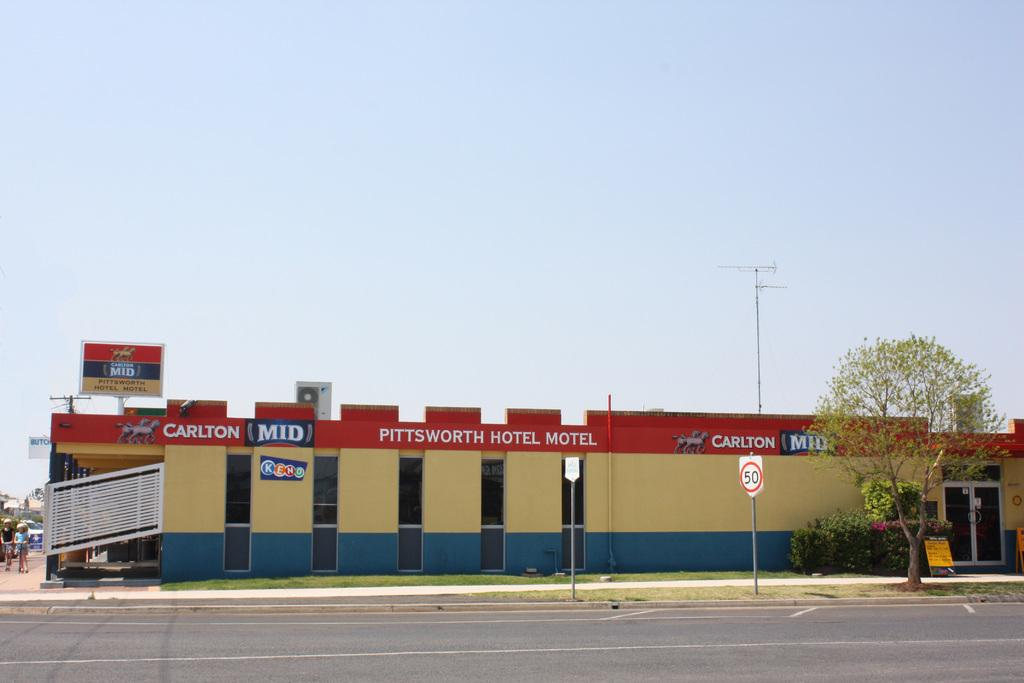What type of building is in the image? There is a hotel in the image. What type of natural elements can be seen in the image? Plants, a tree, and the sky are visible in the image. What man-made structures are present in the image? Boards and poles are present in the image. How many people are in the image? There are two persons standing in the image. What type of pathway is visible in the image? There is a road in the image. What type of fan is visible in the image? There is no fan present in the image. What type of sail can be seen on the dock in the image? There is no dock or sail present in the image. 